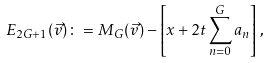<formula> <loc_0><loc_0><loc_500><loc_500>E _ { 2 G + 1 } ( \vec { v } ) \colon = M _ { G } ( \vec { v } ) - \left [ x + 2 t \sum _ { n = 0 } ^ { G } a _ { n } \right ] \, ,</formula> 